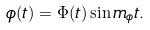<formula> <loc_0><loc_0><loc_500><loc_500>\phi ( t ) = \Phi ( t ) \sin m _ { \phi } t .</formula> 